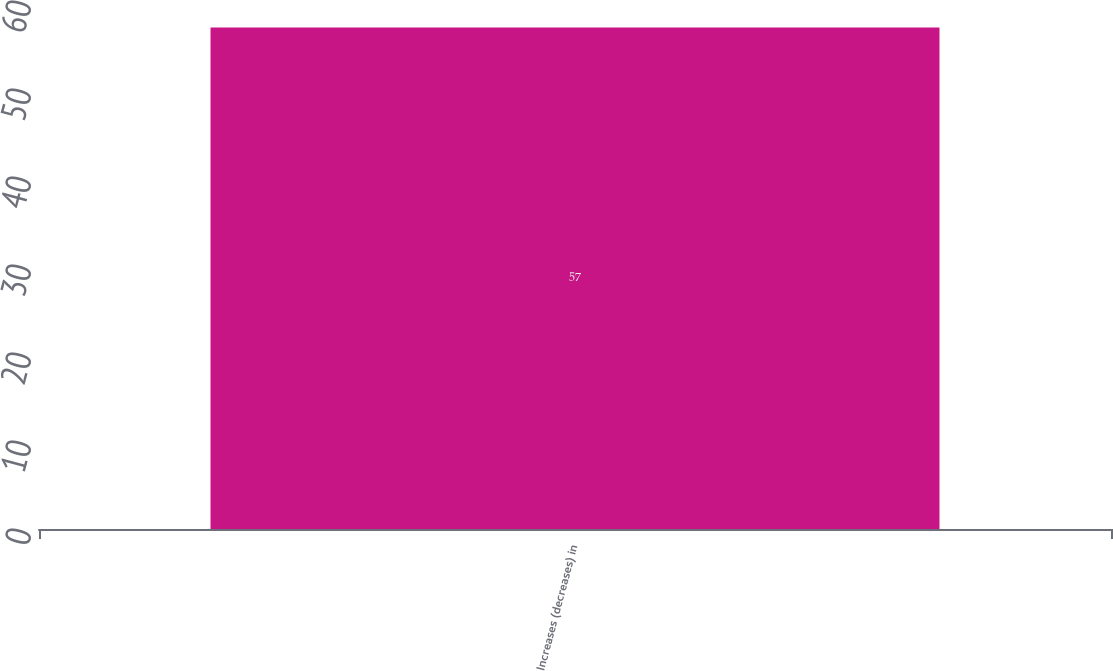Convert chart to OTSL. <chart><loc_0><loc_0><loc_500><loc_500><bar_chart><fcel>Increases (decreases) in<nl><fcel>57<nl></chart> 